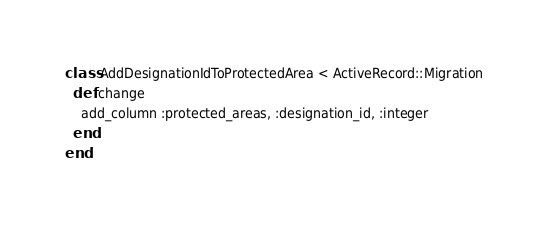Convert code to text. <code><loc_0><loc_0><loc_500><loc_500><_Ruby_>class AddDesignationIdToProtectedArea < ActiveRecord::Migration
  def change
    add_column :protected_areas, :designation_id, :integer
  end
end
</code> 